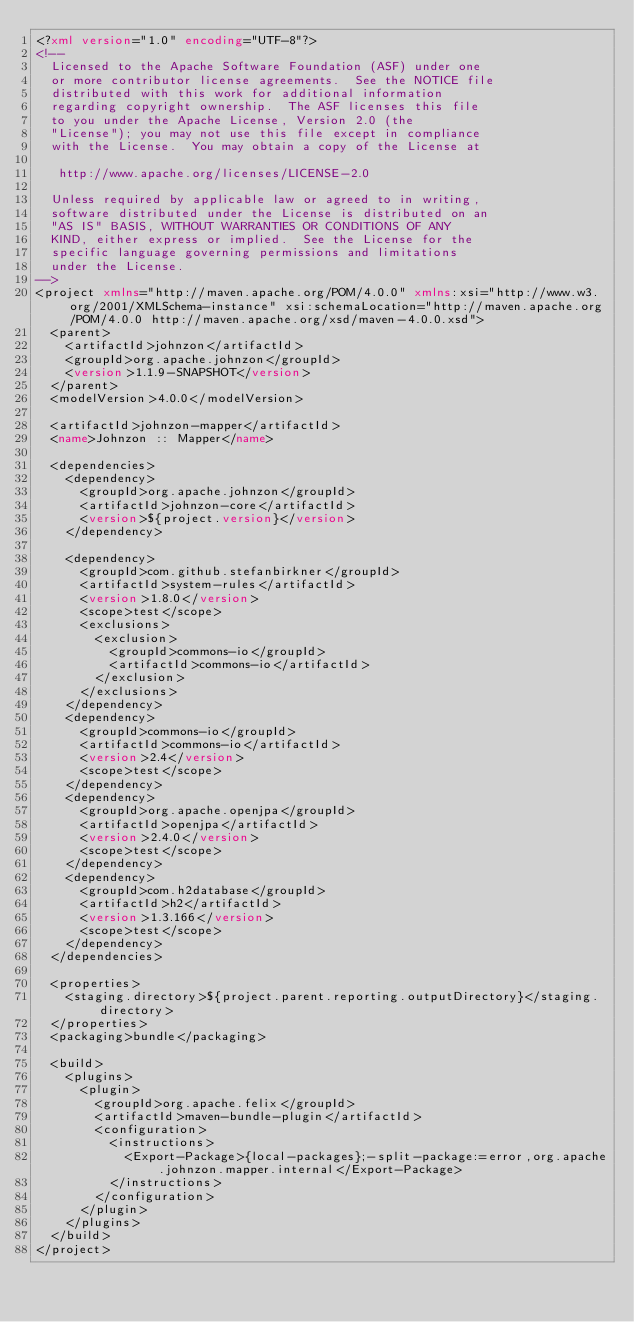<code> <loc_0><loc_0><loc_500><loc_500><_XML_><?xml version="1.0" encoding="UTF-8"?>
<!--
  Licensed to the Apache Software Foundation (ASF) under one
  or more contributor license agreements.  See the NOTICE file
  distributed with this work for additional information
  regarding copyright ownership.  The ASF licenses this file
  to you under the Apache License, Version 2.0 (the
  "License"); you may not use this file except in compliance
  with the License.  You may obtain a copy of the License at

   http://www.apache.org/licenses/LICENSE-2.0

  Unless required by applicable law or agreed to in writing,
  software distributed under the License is distributed on an
  "AS IS" BASIS, WITHOUT WARRANTIES OR CONDITIONS OF ANY
  KIND, either express or implied.  See the License for the
  specific language governing permissions and limitations
  under the License.
-->
<project xmlns="http://maven.apache.org/POM/4.0.0" xmlns:xsi="http://www.w3.org/2001/XMLSchema-instance" xsi:schemaLocation="http://maven.apache.org/POM/4.0.0 http://maven.apache.org/xsd/maven-4.0.0.xsd">
  <parent>
    <artifactId>johnzon</artifactId>
    <groupId>org.apache.johnzon</groupId>
    <version>1.1.9-SNAPSHOT</version>
  </parent>
  <modelVersion>4.0.0</modelVersion>

  <artifactId>johnzon-mapper</artifactId>
  <name>Johnzon :: Mapper</name>

  <dependencies>
    <dependency>
      <groupId>org.apache.johnzon</groupId>
      <artifactId>johnzon-core</artifactId>
      <version>${project.version}</version>
    </dependency>

    <dependency>
      <groupId>com.github.stefanbirkner</groupId>
      <artifactId>system-rules</artifactId>
      <version>1.8.0</version>
      <scope>test</scope>
      <exclusions>
        <exclusion>
          <groupId>commons-io</groupId>
          <artifactId>commons-io</artifactId>
        </exclusion>
      </exclusions>
    </dependency>
    <dependency>
      <groupId>commons-io</groupId>
      <artifactId>commons-io</artifactId>
      <version>2.4</version>
      <scope>test</scope>
    </dependency>
    <dependency>
      <groupId>org.apache.openjpa</groupId>
      <artifactId>openjpa</artifactId>
      <version>2.4.0</version>
      <scope>test</scope>
    </dependency>
    <dependency>
      <groupId>com.h2database</groupId>
      <artifactId>h2</artifactId>
      <version>1.3.166</version>
      <scope>test</scope>
    </dependency>
  </dependencies>

  <properties>
    <staging.directory>${project.parent.reporting.outputDirectory}</staging.directory>
  </properties>
  <packaging>bundle</packaging>

  <build>
    <plugins>
      <plugin>
        <groupId>org.apache.felix</groupId>
        <artifactId>maven-bundle-plugin</artifactId>
        <configuration>
          <instructions>
            <Export-Package>{local-packages};-split-package:=error,org.apache.johnzon.mapper.internal</Export-Package>
          </instructions>
        </configuration>
      </plugin>
    </plugins>
  </build>
</project>
</code> 